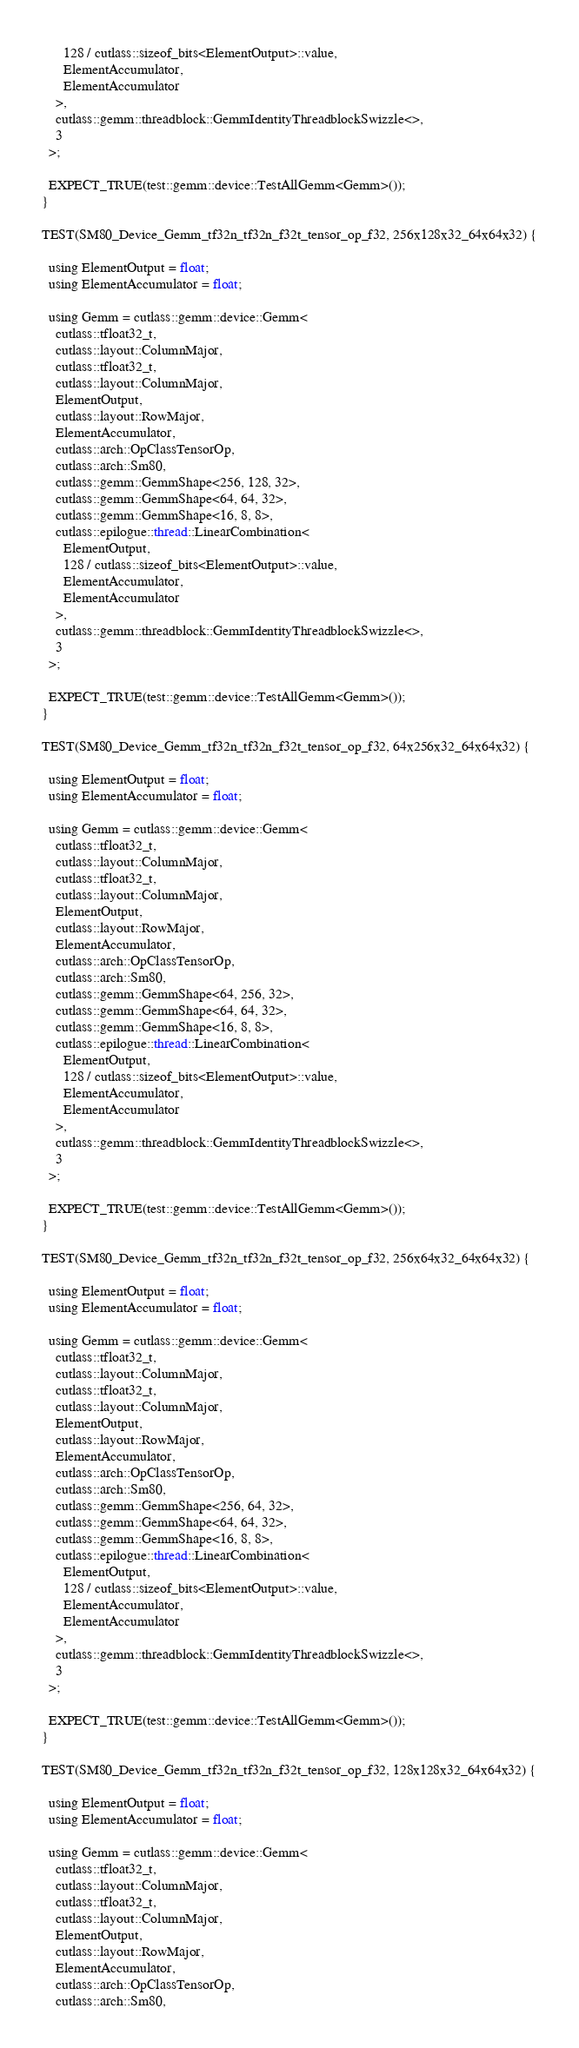Convert code to text. <code><loc_0><loc_0><loc_500><loc_500><_Cuda_>      128 / cutlass::sizeof_bits<ElementOutput>::value,
      ElementAccumulator,
      ElementAccumulator
    >,
    cutlass::gemm::threadblock::GemmIdentityThreadblockSwizzle<>,
    3
  >;

  EXPECT_TRUE(test::gemm::device::TestAllGemm<Gemm>());
}

TEST(SM80_Device_Gemm_tf32n_tf32n_f32t_tensor_op_f32, 256x128x32_64x64x32) {

  using ElementOutput = float;
  using ElementAccumulator = float;

  using Gemm = cutlass::gemm::device::Gemm<
    cutlass::tfloat32_t,
    cutlass::layout::ColumnMajor,
    cutlass::tfloat32_t,
    cutlass::layout::ColumnMajor,
    ElementOutput,
    cutlass::layout::RowMajor,
    ElementAccumulator,
    cutlass::arch::OpClassTensorOp,
    cutlass::arch::Sm80,
    cutlass::gemm::GemmShape<256, 128, 32>,
    cutlass::gemm::GemmShape<64, 64, 32>,
    cutlass::gemm::GemmShape<16, 8, 8>,
    cutlass::epilogue::thread::LinearCombination<
      ElementOutput,
      128 / cutlass::sizeof_bits<ElementOutput>::value,
      ElementAccumulator,
      ElementAccumulator
    >,
    cutlass::gemm::threadblock::GemmIdentityThreadblockSwizzle<>,
    3
  >;

  EXPECT_TRUE(test::gemm::device::TestAllGemm<Gemm>());
}

TEST(SM80_Device_Gemm_tf32n_tf32n_f32t_tensor_op_f32, 64x256x32_64x64x32) {

  using ElementOutput = float;
  using ElementAccumulator = float;

  using Gemm = cutlass::gemm::device::Gemm<
    cutlass::tfloat32_t,
    cutlass::layout::ColumnMajor,
    cutlass::tfloat32_t,
    cutlass::layout::ColumnMajor,
    ElementOutput,
    cutlass::layout::RowMajor,
    ElementAccumulator,
    cutlass::arch::OpClassTensorOp,
    cutlass::arch::Sm80,
    cutlass::gemm::GemmShape<64, 256, 32>,
    cutlass::gemm::GemmShape<64, 64, 32>,
    cutlass::gemm::GemmShape<16, 8, 8>,
    cutlass::epilogue::thread::LinearCombination<
      ElementOutput,
      128 / cutlass::sizeof_bits<ElementOutput>::value,
      ElementAccumulator,
      ElementAccumulator
    >,
    cutlass::gemm::threadblock::GemmIdentityThreadblockSwizzle<>,
    3
  >;

  EXPECT_TRUE(test::gemm::device::TestAllGemm<Gemm>());
}

TEST(SM80_Device_Gemm_tf32n_tf32n_f32t_tensor_op_f32, 256x64x32_64x64x32) {

  using ElementOutput = float;
  using ElementAccumulator = float;

  using Gemm = cutlass::gemm::device::Gemm<
    cutlass::tfloat32_t,
    cutlass::layout::ColumnMajor,
    cutlass::tfloat32_t,
    cutlass::layout::ColumnMajor,
    ElementOutput,
    cutlass::layout::RowMajor,
    ElementAccumulator,
    cutlass::arch::OpClassTensorOp,
    cutlass::arch::Sm80,
    cutlass::gemm::GemmShape<256, 64, 32>,
    cutlass::gemm::GemmShape<64, 64, 32>,
    cutlass::gemm::GemmShape<16, 8, 8>,
    cutlass::epilogue::thread::LinearCombination<
      ElementOutput,
      128 / cutlass::sizeof_bits<ElementOutput>::value,
      ElementAccumulator,
      ElementAccumulator
    >,
    cutlass::gemm::threadblock::GemmIdentityThreadblockSwizzle<>,
    3
  >;

  EXPECT_TRUE(test::gemm::device::TestAllGemm<Gemm>());
}

TEST(SM80_Device_Gemm_tf32n_tf32n_f32t_tensor_op_f32, 128x128x32_64x64x32) {

  using ElementOutput = float;
  using ElementAccumulator = float;

  using Gemm = cutlass::gemm::device::Gemm<
    cutlass::tfloat32_t,
    cutlass::layout::ColumnMajor,
    cutlass::tfloat32_t,
    cutlass::layout::ColumnMajor,
    ElementOutput,
    cutlass::layout::RowMajor,
    ElementAccumulator,
    cutlass::arch::OpClassTensorOp,
    cutlass::arch::Sm80,</code> 